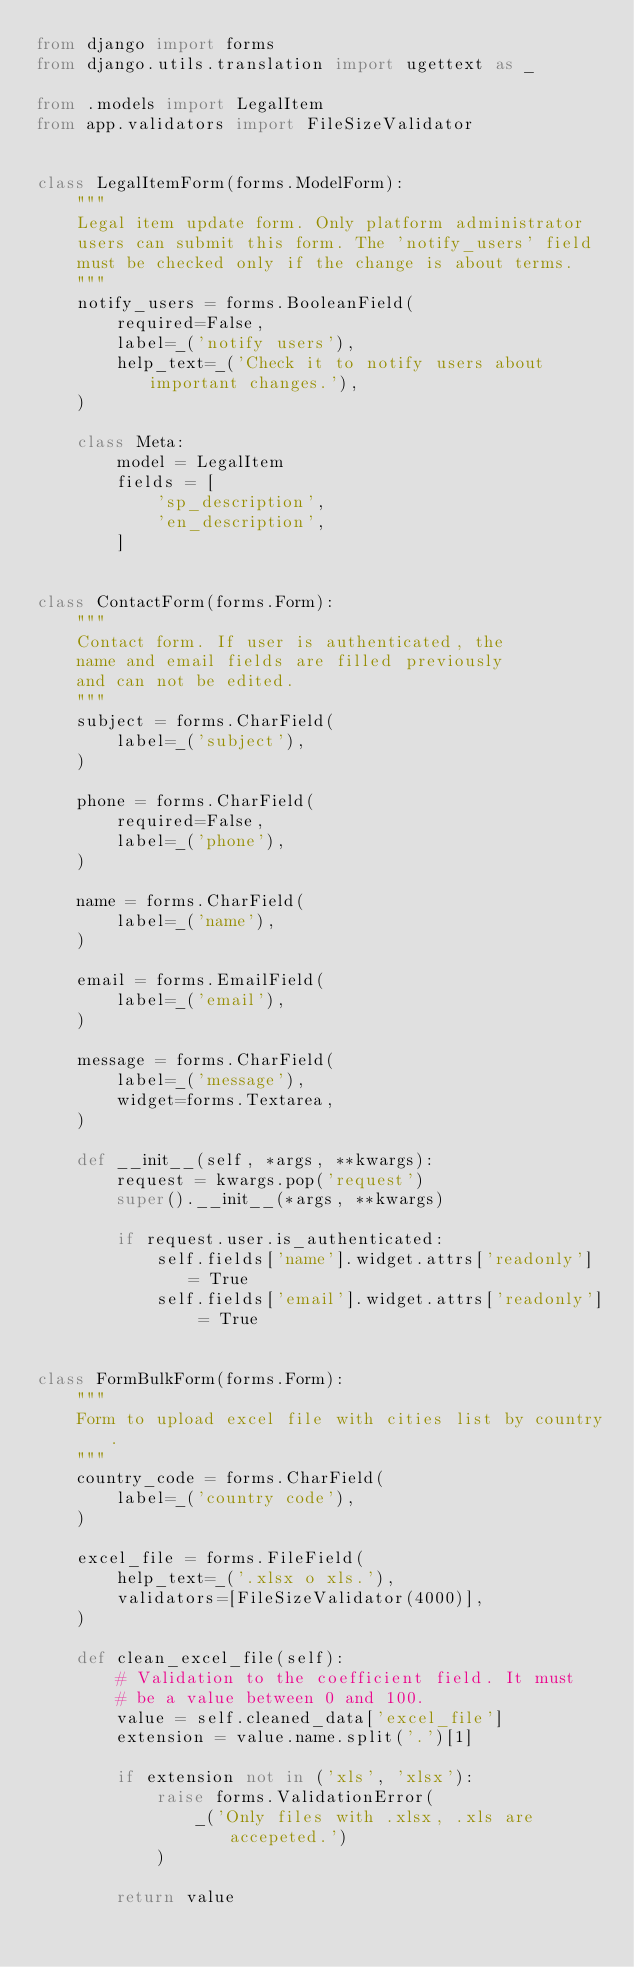<code> <loc_0><loc_0><loc_500><loc_500><_Python_>from django import forms
from django.utils.translation import ugettext as _

from .models import LegalItem
from app.validators import FileSizeValidator


class LegalItemForm(forms.ModelForm):
    """
    Legal item update form. Only platform administrator
    users can submit this form. The 'notify_users' field
    must be checked only if the change is about terms.
    """
    notify_users = forms.BooleanField(
        required=False,
        label=_('notify users'),
        help_text=_('Check it to notify users about important changes.'),
    )

    class Meta:
        model = LegalItem
        fields = [
            'sp_description',
            'en_description',
        ]


class ContactForm(forms.Form):
    """
    Contact form. If user is authenticated, the
    name and email fields are filled previously
    and can not be edited.
    """
    subject = forms.CharField(
        label=_('subject'),
    )

    phone = forms.CharField(
        required=False,
        label=_('phone'),
    )

    name = forms.CharField(
        label=_('name'),
    )

    email = forms.EmailField(
        label=_('email'),
    )

    message = forms.CharField(
        label=_('message'),
        widget=forms.Textarea,
    )

    def __init__(self, *args, **kwargs):
        request = kwargs.pop('request')
        super().__init__(*args, **kwargs)

        if request.user.is_authenticated:
            self.fields['name'].widget.attrs['readonly'] = True
            self.fields['email'].widget.attrs['readonly'] = True


class FormBulkForm(forms.Form):
    """
    Form to upload excel file with cities list by country.
    """
    country_code = forms.CharField(
        label=_('country code'),
    )

    excel_file = forms.FileField(
        help_text=_('.xlsx o xls.'),
        validators=[FileSizeValidator(4000)],
    )

    def clean_excel_file(self):
        # Validation to the coefficient field. It must
        # be a value between 0 and 100.
        value = self.cleaned_data['excel_file']
        extension = value.name.split('.')[1]

        if extension not in ('xls', 'xlsx'):
            raise forms.ValidationError(
                _('Only files with .xlsx, .xls are accepeted.')
            )

        return value
</code> 